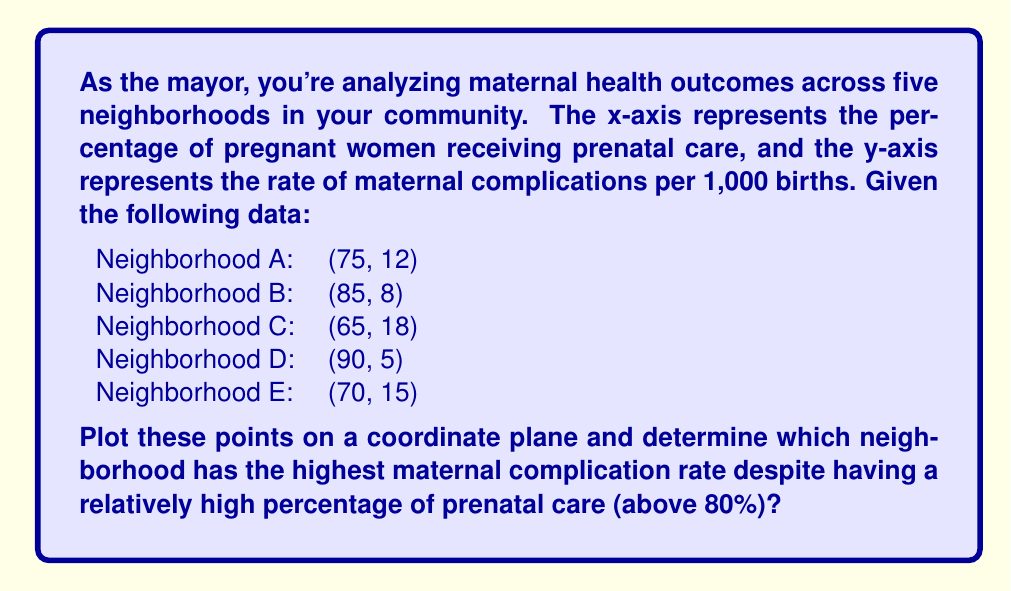What is the answer to this math problem? To solve this problem, we need to follow these steps:

1. Plot the given points on a coordinate plane.
2. Identify the neighborhoods with prenatal care percentages above 80%.
3. Among those neighborhoods, determine which has the highest maternal complication rate.

Let's plot the points:

[asy]
size(200);
import graph;

// Set up the coordinate system
xaxis("Prenatal Care (%)", 0, 100, arrow=Arrow);
yaxis("Maternal Complications (per 1,000 births)", 0, 20, arrow=Arrow);

// Plot the points
dot((75,12));
dot((85,8));
dot((65,18));
dot((90,5));
dot((70,15));

// Label the points
label("A", (75,12), NE);
label("B", (85,8), NE);
label("C", (65,18), NW);
label("D", (90,5), SE);
label("E", (70,15), NW);
[/asy]

Now, let's analyze the data:

1. Neighborhoods with prenatal care percentages above 80%:
   - Neighborhood B: (85, 8)
   - Neighborhood D: (90, 5)

2. Comparing maternal complication rates:
   - Neighborhood B: 8 per 1,000 births
   - Neighborhood D: 5 per 1,000 births

Among the neighborhoods with prenatal care percentages above 80%, Neighborhood B has the higher maternal complication rate.
Answer: Neighborhood B 